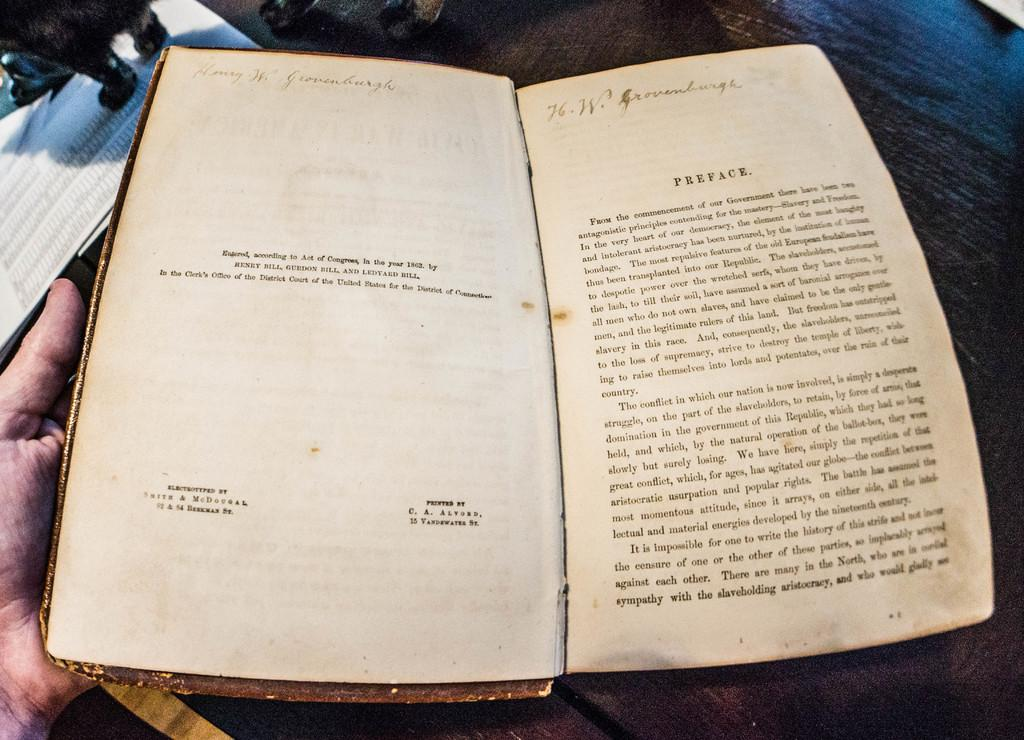<image>
Render a clear and concise summary of the photo. Book opened on the Preface which was printed by C.A. Alvord. 